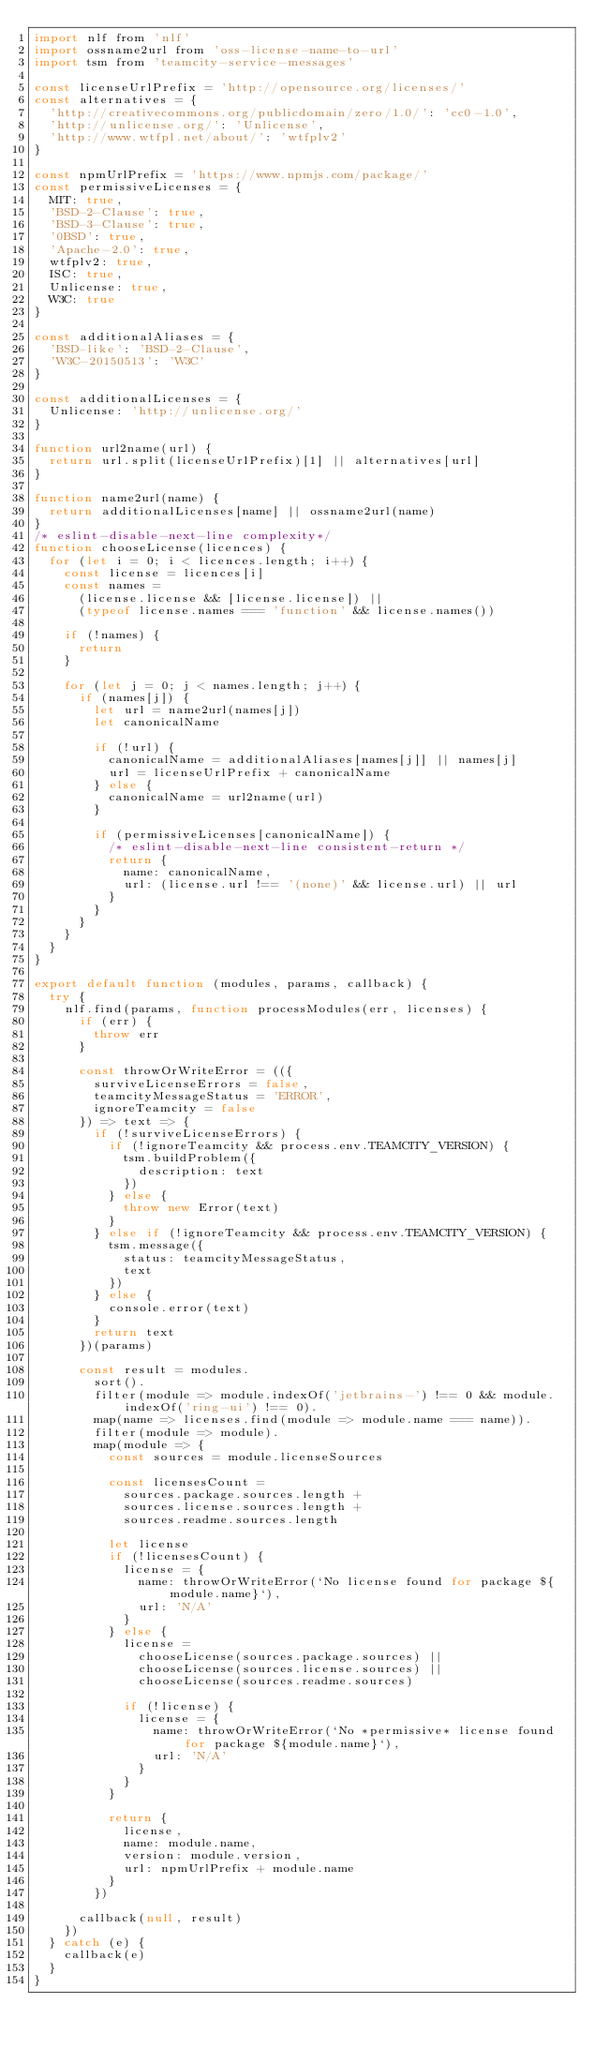<code> <loc_0><loc_0><loc_500><loc_500><_JavaScript_>import nlf from 'nlf'
import ossname2url from 'oss-license-name-to-url'
import tsm from 'teamcity-service-messages'

const licenseUrlPrefix = 'http://opensource.org/licenses/'
const alternatives = {
  'http://creativecommons.org/publicdomain/zero/1.0/': 'cc0-1.0',
  'http://unlicense.org/': 'Unlicense',
  'http://www.wtfpl.net/about/': 'wtfplv2'
}

const npmUrlPrefix = 'https://www.npmjs.com/package/'
const permissiveLicenses = {
  MIT: true,
  'BSD-2-Clause': true,
  'BSD-3-Clause': true,
  '0BSD': true,
  'Apache-2.0': true,
  wtfplv2: true,
  ISC: true,
  Unlicense: true,
  W3C: true
}

const additionalAliases = {
  'BSD-like': 'BSD-2-Clause',
  'W3C-20150513': 'W3C'
}

const additionalLicenses = {
  Unlicense: 'http://unlicense.org/'
}

function url2name(url) {
  return url.split(licenseUrlPrefix)[1] || alternatives[url]
}

function name2url(name) {
  return additionalLicenses[name] || ossname2url(name)
}
/* eslint-disable-next-line complexity*/
function chooseLicense(licences) {
  for (let i = 0; i < licences.length; i++) {
    const license = licences[i]
    const names =
      (license.license && [license.license]) ||
      (typeof license.names === 'function' && license.names())

    if (!names) {
      return
    }

    for (let j = 0; j < names.length; j++) {
      if (names[j]) {
        let url = name2url(names[j])
        let canonicalName

        if (!url) {
          canonicalName = additionalAliases[names[j]] || names[j]
          url = licenseUrlPrefix + canonicalName
        } else {
          canonicalName = url2name(url)
        }

        if (permissiveLicenses[canonicalName]) {
          /* eslint-disable-next-line consistent-return */
          return {
            name: canonicalName,
            url: (license.url !== '(none)' && license.url) || url
          }
        }
      }
    }
  }
}

export default function (modules, params, callback) {
  try {
    nlf.find(params, function processModules(err, licenses) {
      if (err) {
        throw err
      }

      const throwOrWriteError = (({
        surviveLicenseErrors = false,
        teamcityMessageStatus = 'ERROR',
        ignoreTeamcity = false
      }) => text => {
        if (!surviveLicenseErrors) {
          if (!ignoreTeamcity && process.env.TEAMCITY_VERSION) {
            tsm.buildProblem({
              description: text
            })
          } else {
            throw new Error(text)
          }
        } else if (!ignoreTeamcity && process.env.TEAMCITY_VERSION) {
          tsm.message({
            status: teamcityMessageStatus,
            text
          })
        } else {
          console.error(text)
        }
        return text
      })(params)

      const result = modules.
        sort().
        filter(module => module.indexOf('jetbrains-') !== 0 && module.indexOf('ring-ui') !== 0).
        map(name => licenses.find(module => module.name === name)).
        filter(module => module).
        map(module => {
          const sources = module.licenseSources

          const licensesCount =
            sources.package.sources.length +
            sources.license.sources.length +
            sources.readme.sources.length

          let license
          if (!licensesCount) {
            license = {
              name: throwOrWriteError(`No license found for package ${module.name}`),
              url: 'N/A'
            }
          } else {
            license =
              chooseLicense(sources.package.sources) ||
              chooseLicense(sources.license.sources) ||
              chooseLicense(sources.readme.sources)

            if (!license) {
              license = {
                name: throwOrWriteError(`No *permissive* license found for package ${module.name}`),
                url: 'N/A'
              }
            }
          }

          return {
            license,
            name: module.name,
            version: module.version,
            url: npmUrlPrefix + module.name
          }
        })

      callback(null, result)
    })
  } catch (e) {
    callback(e)
  }
}
</code> 